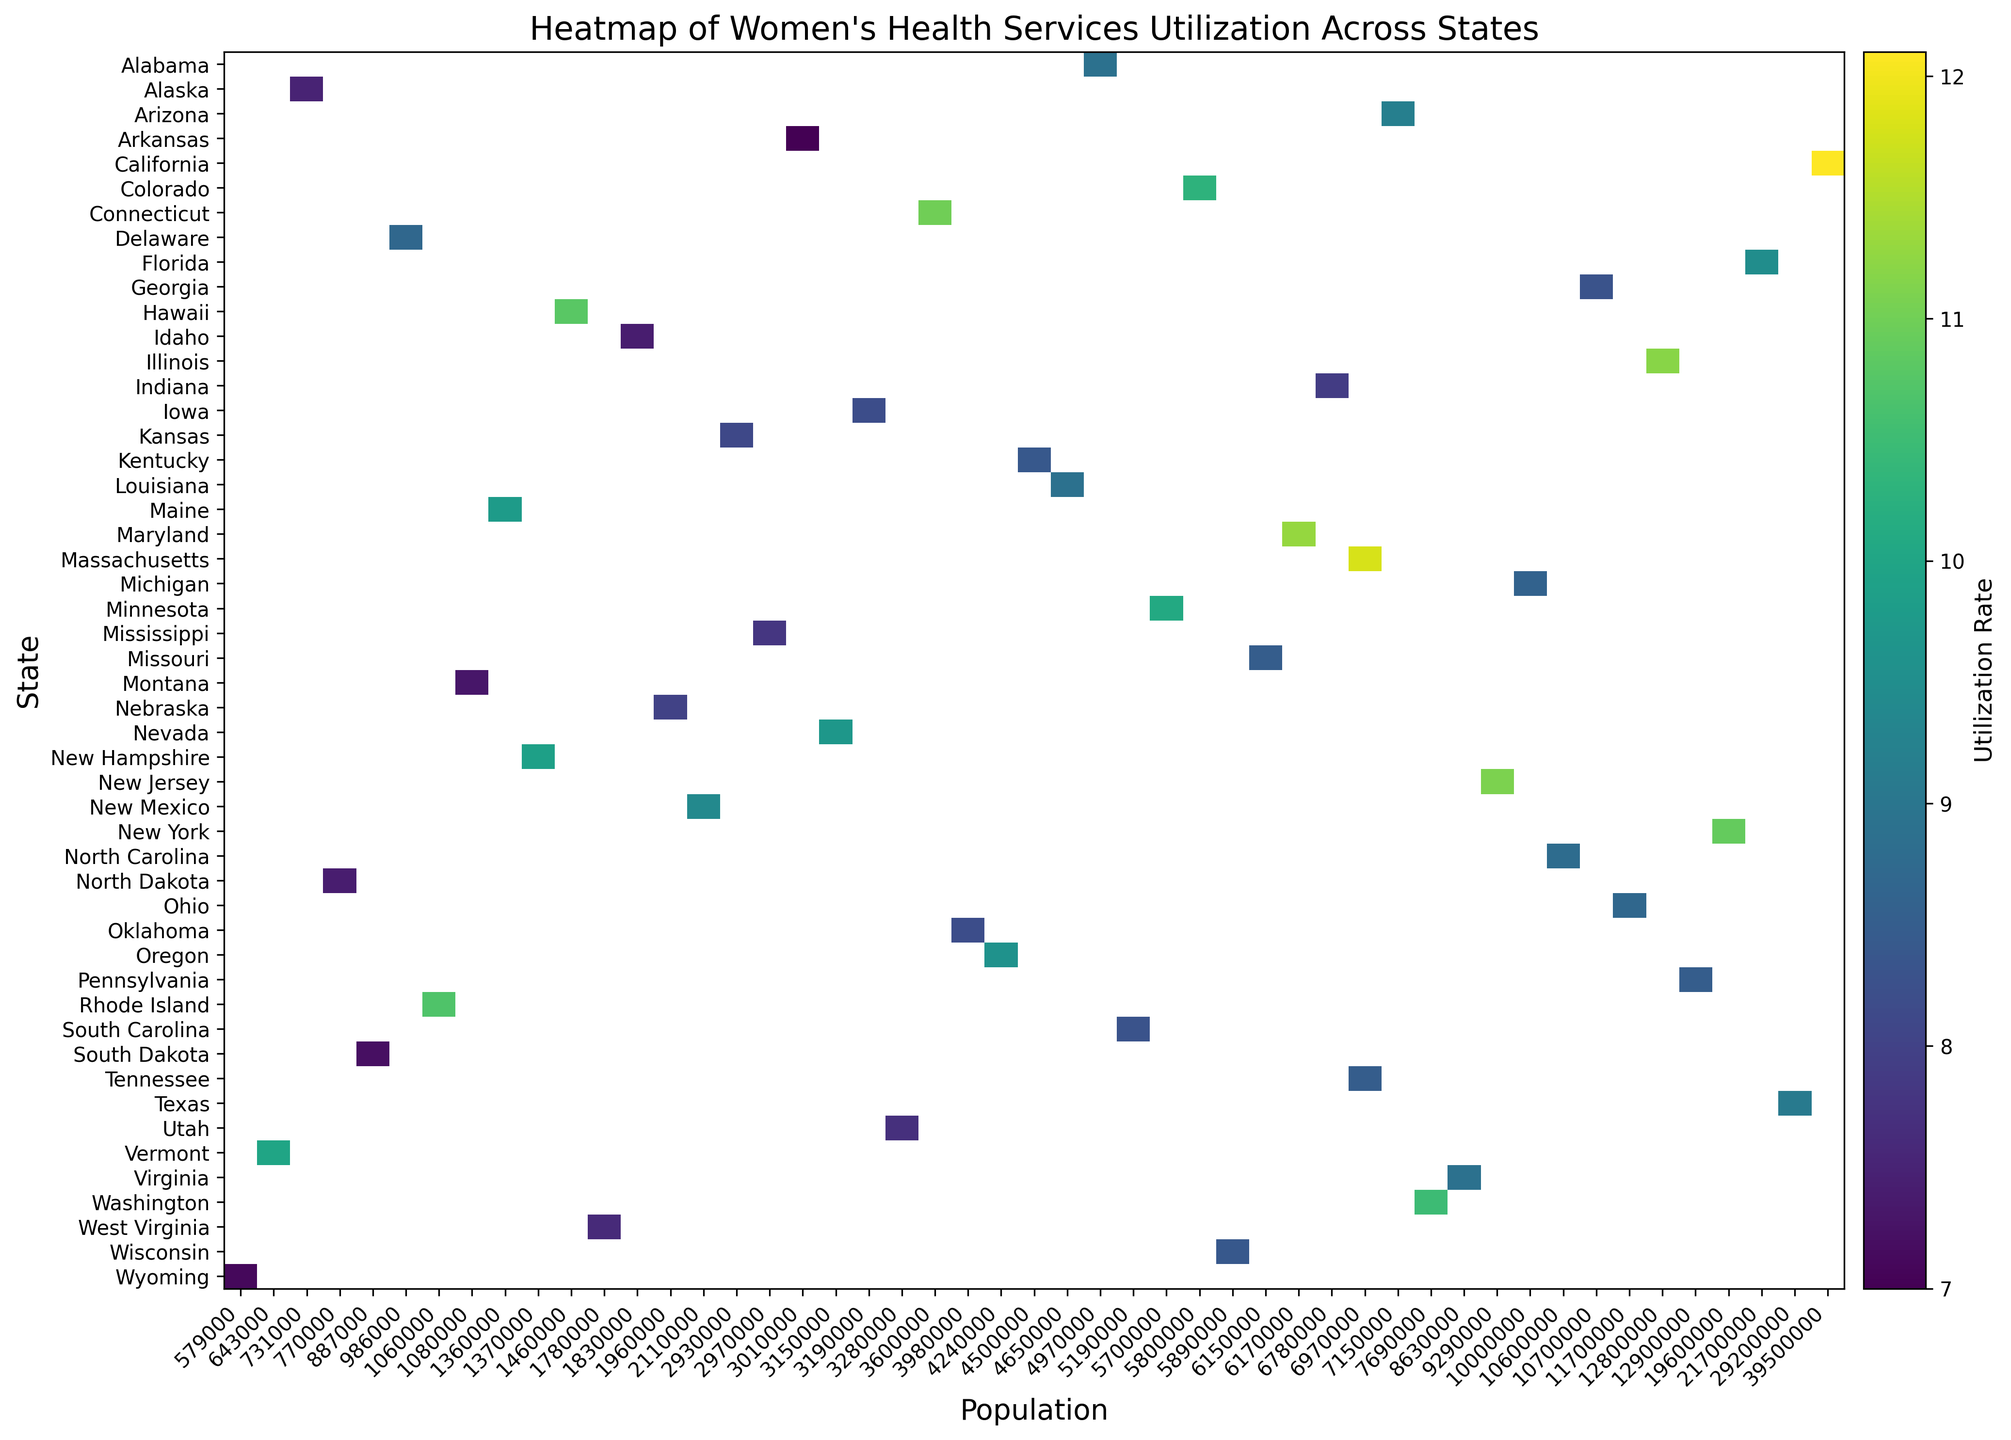Which state has the highest utilization rate for women's health services? Look for the state with the darkest color on the heatmap, which indicates the highest utilization rate.
Answer: California How does the utilization rate in Texas compare to that in Florida? Locate Texas and Florida on the heatmap and compare the shades representing their utilization rates. Texas will have a slightly lighter shade than Florida.
Answer: Lower Which states have a utilization rate between 7.0 and 8.0? Identify the states with the corresponding color shades on the heatmap, representing the 7.0 to 8.0 utilization rate range.
Answer: Arkansas, Idaho, Indiana, Mississippi, Montana, Nebraska, North Dakota, South Dakota, Utah, Wyoming Is the utilization rate in Virginia higher than in Kentucky? Find Virginia and Kentucky on the heatmap and compare the shades representing their utilization rates. Virginia's color will be slightly darker.
Answer: Yes Compare the utilization rates of states on the East Coast (Maine, New Hampshire, Massachusetts, Rhode Island, Connecticut, New York, New Jersey, Delaware, Maryland, Virginia, and Florida). Which state has the highest utilization rate among these? Identify the listed East Coast states on the heatmap and compare their utilization rates. The state with the darkest color will indicate the highest utilization rate.
Answer: Massachusetts 